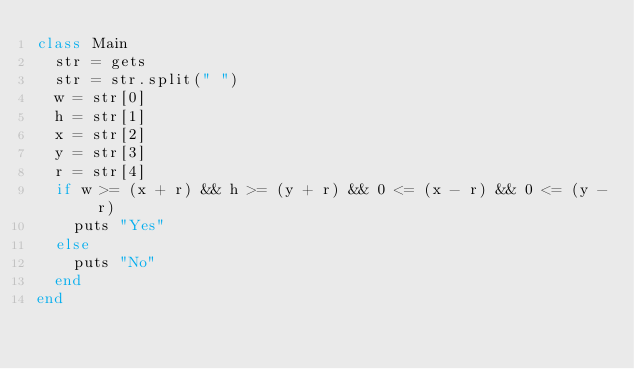<code> <loc_0><loc_0><loc_500><loc_500><_Ruby_>class Main
  str = gets
  str = str.split(" ")
  w = str[0]
  h = str[1]
  x = str[2]
  y = str[3]
  r = str[4]
  if w >= (x + r) && h >= (y + r) && 0 <= (x - r) && 0 <= (y - r)
    puts "Yes"
  else 
    puts "No"
  end
end
</code> 